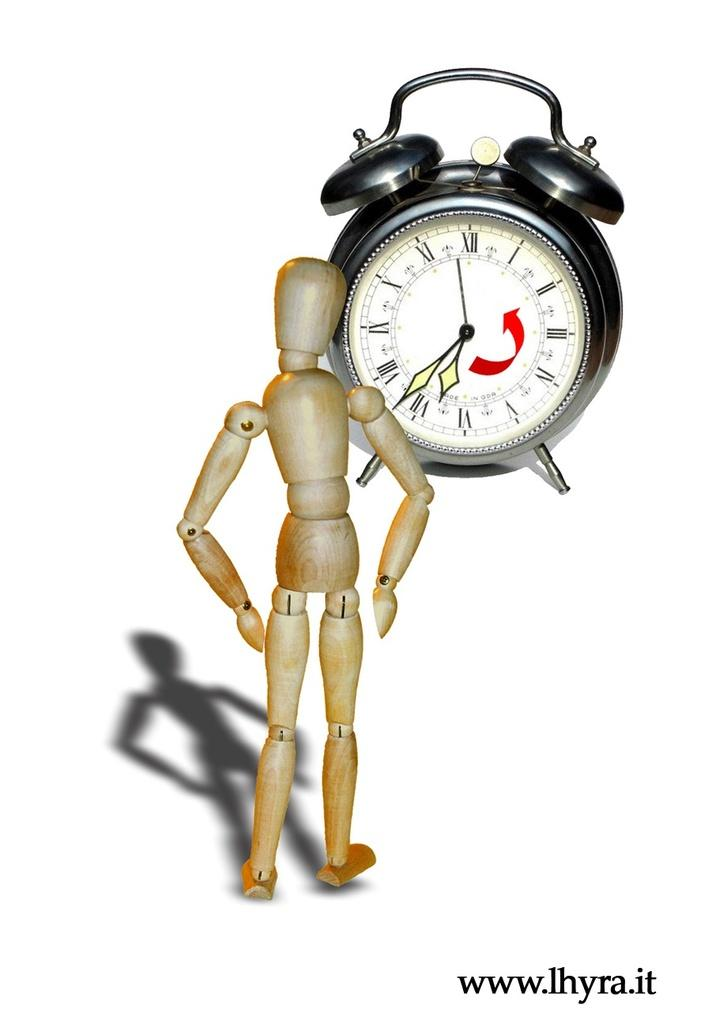Provide a one-sentence caption for the provided image. a wooden man is looking at at clock that says 7:37. 